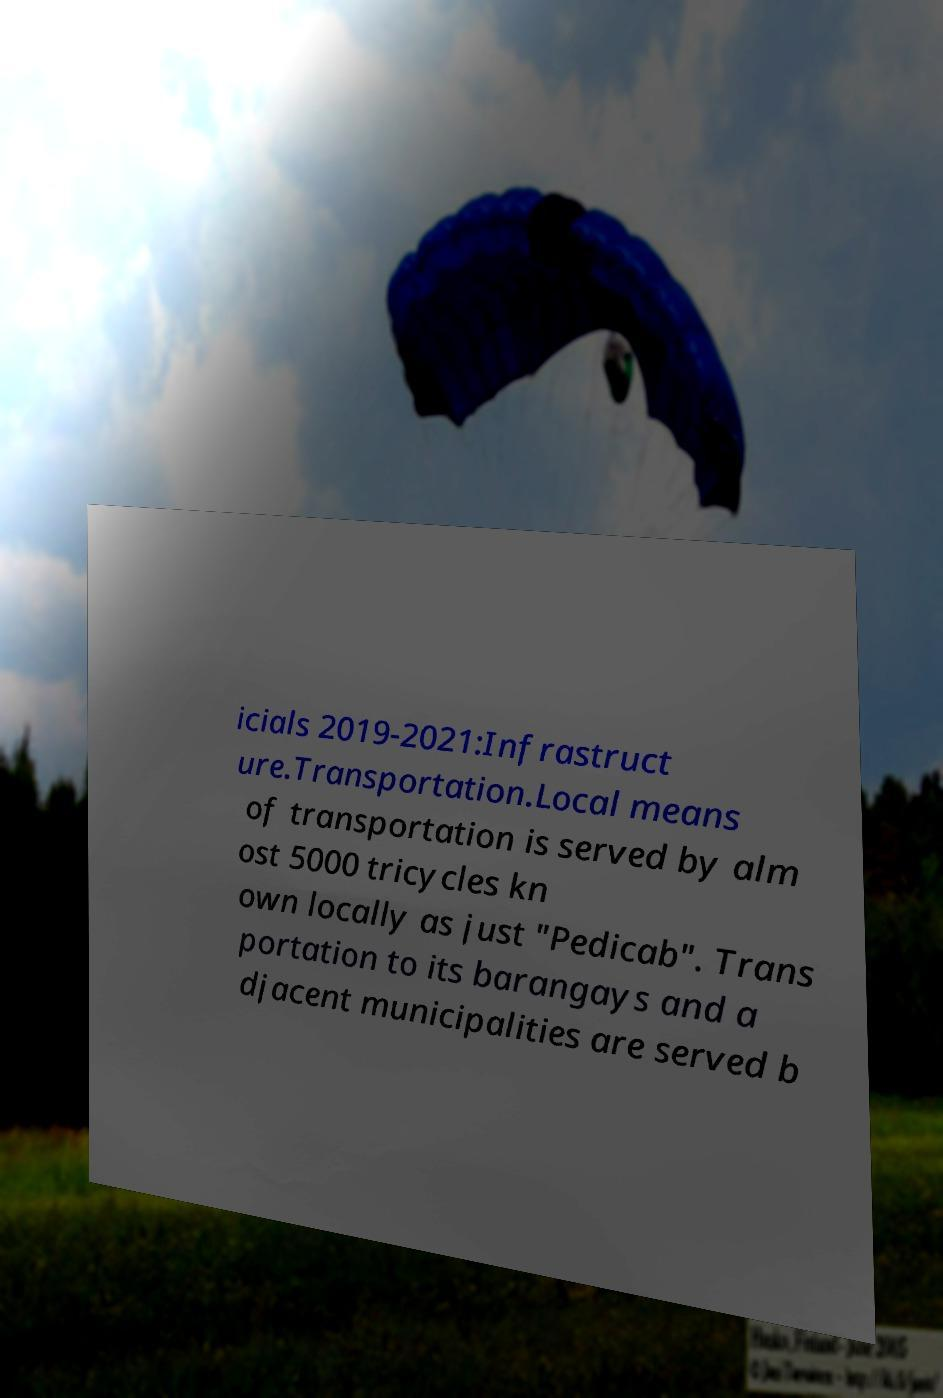What messages or text are displayed in this image? I need them in a readable, typed format. icials 2019-2021:Infrastruct ure.Transportation.Local means of transportation is served by alm ost 5000 tricycles kn own locally as just "Pedicab". Trans portation to its barangays and a djacent municipalities are served b 